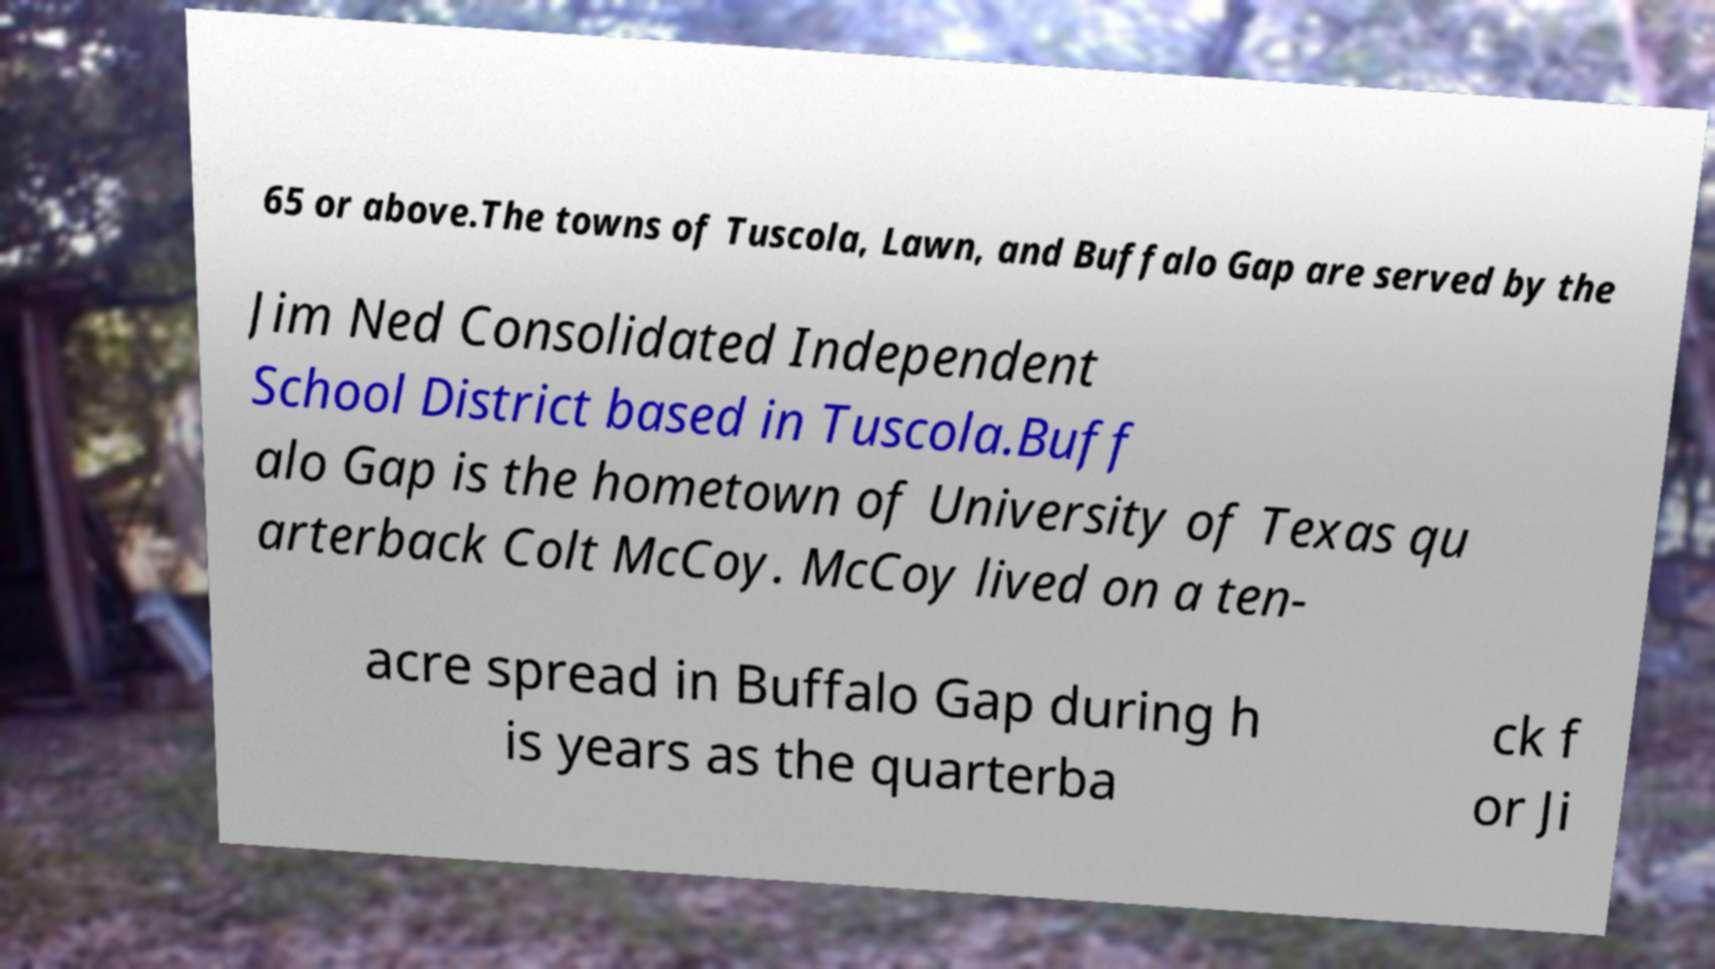For documentation purposes, I need the text within this image transcribed. Could you provide that? 65 or above.The towns of Tuscola, Lawn, and Buffalo Gap are served by the Jim Ned Consolidated Independent School District based in Tuscola.Buff alo Gap is the hometown of University of Texas qu arterback Colt McCoy. McCoy lived on a ten- acre spread in Buffalo Gap during h is years as the quarterba ck f or Ji 